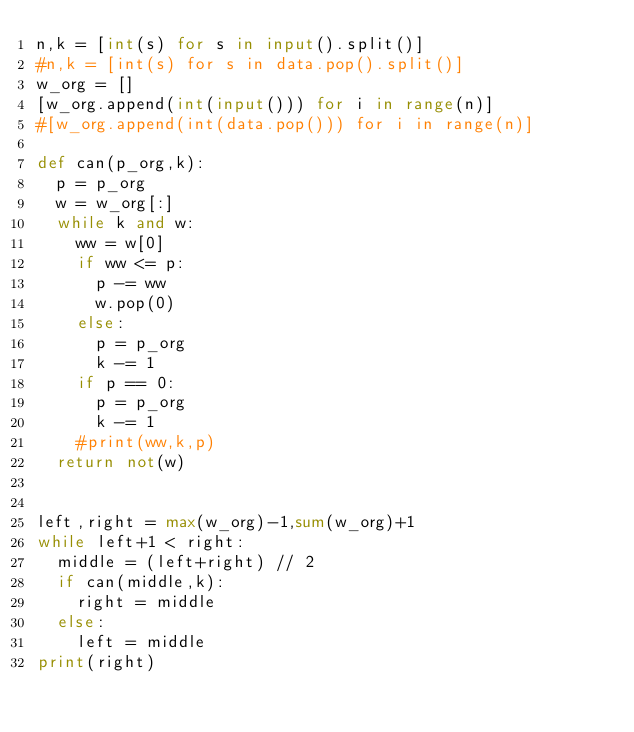Convert code to text. <code><loc_0><loc_0><loc_500><loc_500><_Python_>n,k = [int(s) for s in input().split()]
#n,k = [int(s) for s in data.pop().split()]
w_org = []
[w_org.append(int(input())) for i in range(n)]
#[w_org.append(int(data.pop())) for i in range(n)]

def can(p_org,k):
	p = p_org
	w = w_org[:]
	while k and w:
		ww = w[0]
		if ww <= p:
			p -= ww
			w.pop(0)
		else:
			p = p_org
			k -= 1
		if p == 0:
			p = p_org
			k -= 1
		#print(ww,k,p)
	return not(w)


left,right = max(w_org)-1,sum(w_org)+1
while left+1 < right:
	middle = (left+right) // 2
	if can(middle,k):
		right = middle
	else:
		left = middle
print(right)</code> 